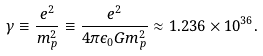Convert formula to latex. <formula><loc_0><loc_0><loc_500><loc_500>\gamma \equiv \frac { e ^ { 2 } } { m _ { p } ^ { 2 } } \equiv \frac { e ^ { 2 } } { 4 \pi \epsilon _ { 0 } G m _ { p } ^ { 2 } } \approx 1 . 2 3 6 \times 1 0 ^ { 3 6 } .</formula> 